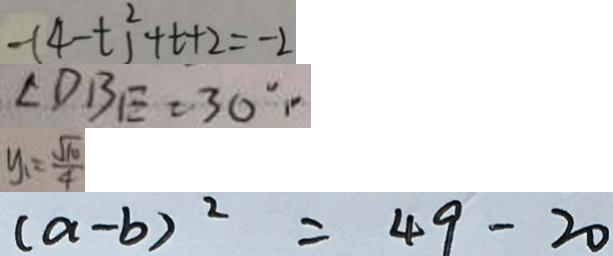Convert formula to latex. <formula><loc_0><loc_0><loc_500><loc_500>- ( 4 - t ^ { 2 } ) ^ { 2 } + t + 2 = - 2 
 \angle D B E = 3 0 ^ { \circ } . 
 y _ { 1 } = \frac { \sqrt { 1 0 } } { 4 } 
 ( a - b ) ^ { 2 } = 4 9 - 2 0</formula> 